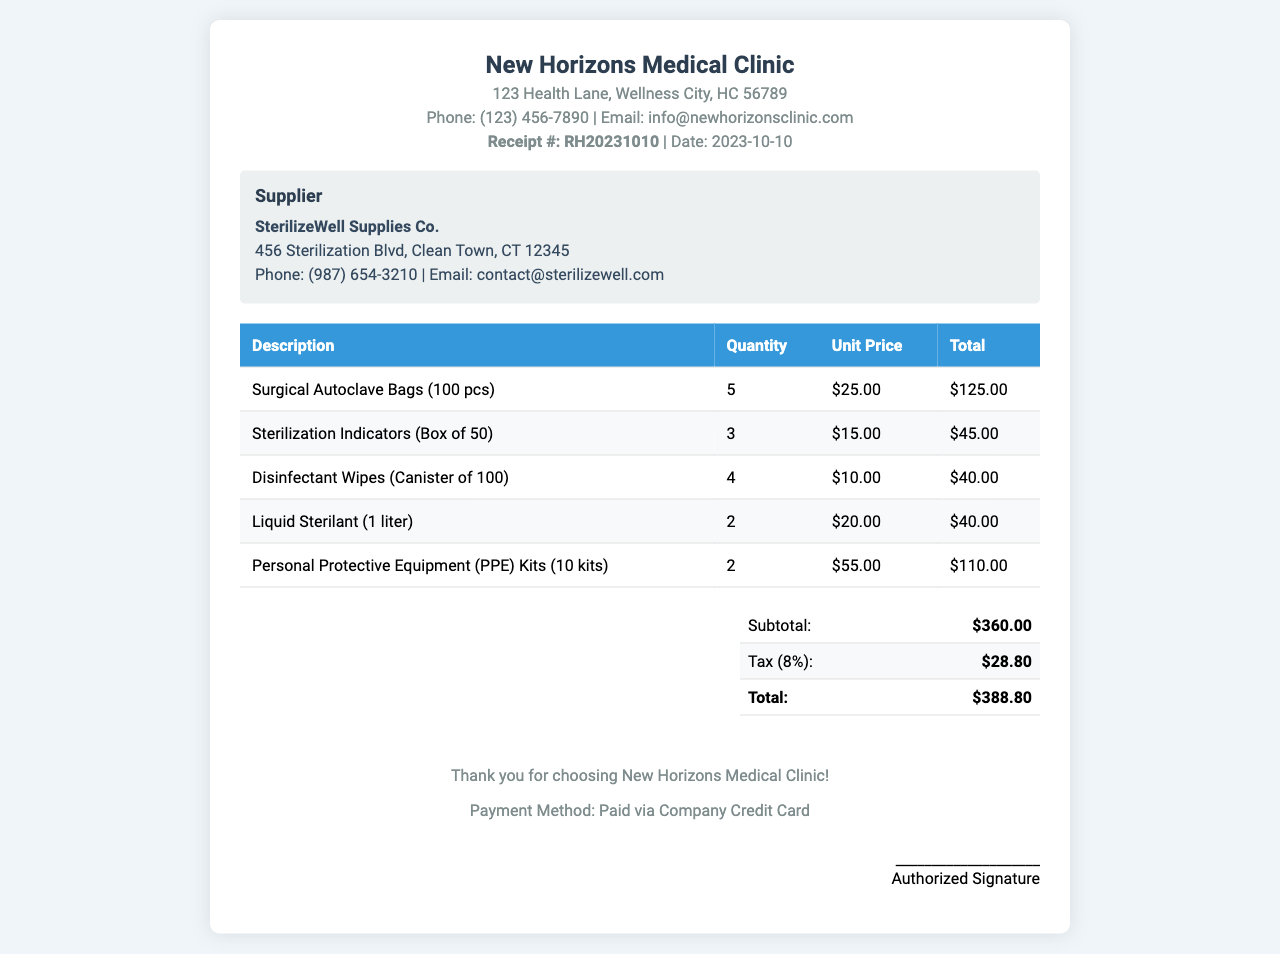What is the receipt number? The receipt number is stated clearly in the document under the header as Receipt #: RH20231010.
Answer: RH20231010 What is the date of the receipt? The date is mentioned next to the receipt number in the header section of the document, which states Date: 2023-10-10.
Answer: 2023-10-10 Who is the supplier? The supplier's name appears in the supplier information section as SterilizeWell Supplies Co.
Answer: SterilizeWell Supplies Co What is the total amount paid? The total amount is calculated in the summary table, where it is listed as Total: $388.80.
Answer: $388.80 How many Surgical Autoclave Bags were ordered? The quantity of Surgical Autoclave Bags is found in the table under Quantity for that item, listed as 5.
Answer: 5 What is the tax rate applied in the billing? The tax details are present in the summary table, which lists Tax (8%): $28.80, indicating an 8% tax rate.
Answer: 8% How many PPE Kits were ordered? This information is available in the table under Quantity for the PPE Kits row, where it states 2.
Answer: 2 What is the price of one box of Sterilization Indicators? The unit price for Sterilization Indicators is given in the table under Unit Price for that specific row as $15.00.
Answer: $15.00 What payment method was used? The payment method is mentioned in the footer of the document as Paid via Company Credit Card.
Answer: Company Credit Card 